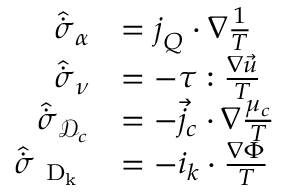Convert formula to latex. <formula><loc_0><loc_0><loc_500><loc_500>\begin{array} { r l } { \hat { \dot { \sigma } } _ { \alpha } } & { = j _ { Q } \cdot { \nabla } { \frac { 1 } { T } } } \\ { \hat { \dot { \sigma } } _ { \nu } } & { = - \tau \colon \frac { \nabla \vec { u } } { T } } \\ { \hat { \dot { \sigma } } _ { \mathcal { D } _ { c } } } & { = - { \vec { j } _ { c } } \cdot { \nabla } \frac { \mu _ { c } } { T } } \\ { \hat { \dot { \sigma } } _ { D _ { k } } } & { = - i _ { k } \cdot \frac { \nabla \Phi } { T } } \end{array}</formula> 